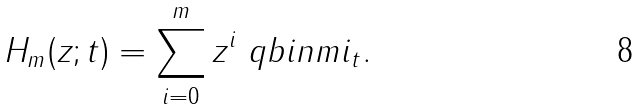Convert formula to latex. <formula><loc_0><loc_0><loc_500><loc_500>H _ { m } ( z ; t ) = \sum _ { i = 0 } ^ { m } z ^ { i } \ q b i n { m } { i } _ { t } .</formula> 